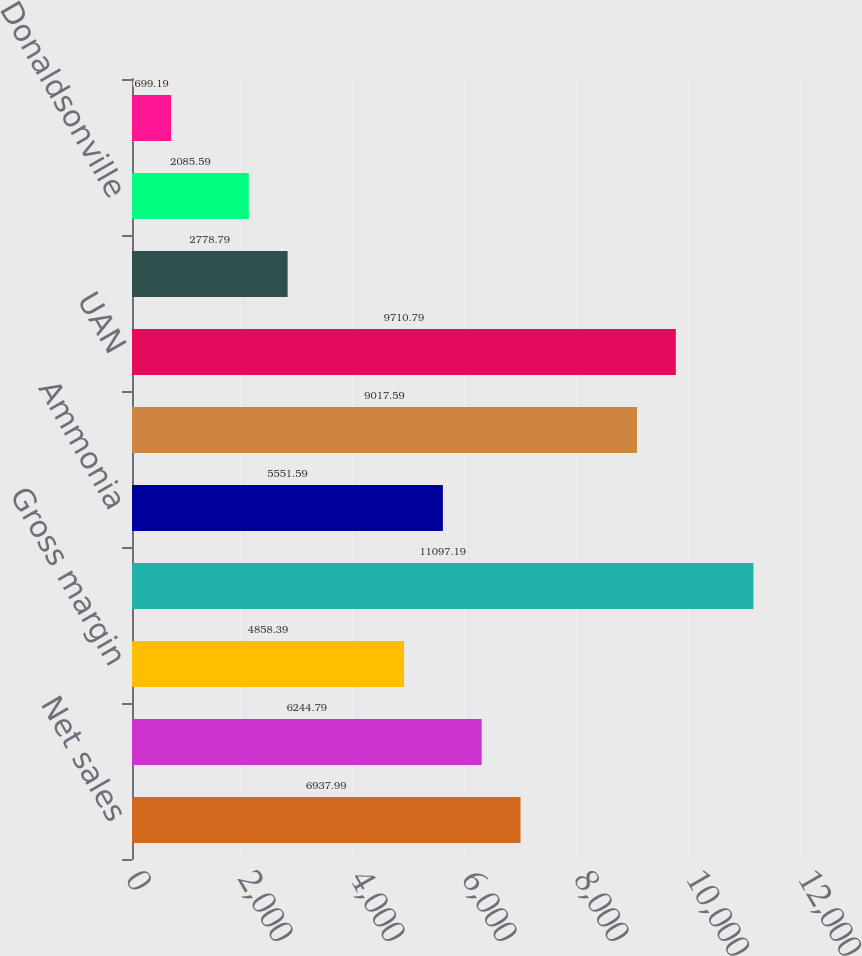Convert chart to OTSL. <chart><loc_0><loc_0><loc_500><loc_500><bar_chart><fcel>Net sales<fcel>Cost of sales<fcel>Gross margin<fcel>Tons of product sold (000s)<fcel>Ammonia<fcel>Urea<fcel>UAN<fcel>Other nitrogen products<fcel>Donaldsonville<fcel>Medicine Hat<nl><fcel>6937.99<fcel>6244.79<fcel>4858.39<fcel>11097.2<fcel>5551.59<fcel>9017.59<fcel>9710.79<fcel>2778.79<fcel>2085.59<fcel>699.19<nl></chart> 